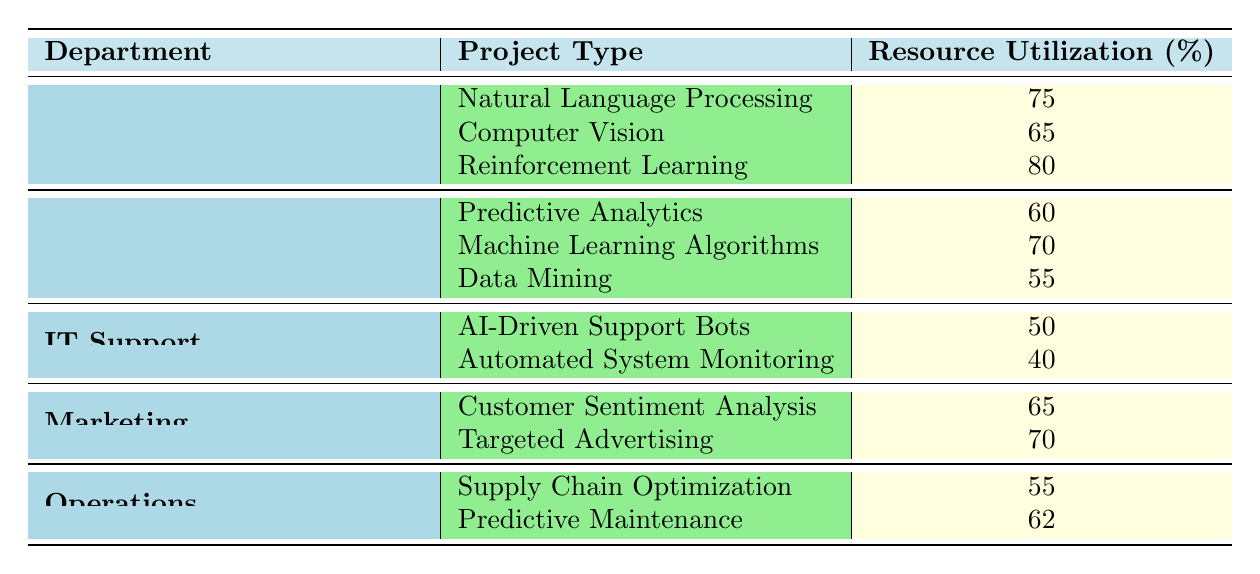What is the resource utilization for Natural Language Processing in the Research and Development department? The table indicates that the resource utilization for Natural Language Processing under the Research and Development department is listed as 75%.
Answer: 75 Which department has the highest resource utilization for its AI project types? By examining the highest individual resource utilization values, Reinforcement Learning in the Research and Development department has the highest value of 80%.
Answer: Research and Development What is the total resource utilization for all AI project types in the Data Science department? The resource utilization values are 60 (Predictive Analytics), 70 (Machine Learning Algorithms), and 55 (Data Mining). Adding these values gives 60 + 70 + 55 = 185.
Answer: 185 Is the resource utilization for AI-Driven Support Bots higher than that of Automated System Monitoring? The resource utilization for AI-Driven Support Bots is 50%, while for Automated System Monitoring it is 40%. Since 50% is greater than 40%, the statement is true.
Answer: Yes What is the average resource utilization across all project types for the Marketing department? The resource utilization values for the Marketing department are 65 (Customer Sentiment Analysis) and 70 (Targeted Advertising). The average is calculated by summing these values (65 + 70 = 135) and dividing by the number of project types (2), resulting in 135 / 2 = 67.5.
Answer: 67.5 Which project type in the Operations department has a resource utilization percentage closest to the value of 60%? In the Operations department, the project types have resource utilizations of 55% (Supply Chain Optimization) and 62% (Predictive Maintenance). The project type Predictive Maintenance (62%) is closer to 60%.
Answer: Predictive Maintenance What is the difference in resource utilization between the highest and lowest project types in the IT Support department? The resource utilization values are 50% (AI-Driven Support Bots) and 40% (Automated System Monitoring). The difference is calculated by subtracting the lower value from the higher value: 50 - 40 = 10%.
Answer: 10 How many departments have a project type with resource utilization above 70%? The Research and Development department has one project type (Reinforcement Learning) at 80%, and the Data Science department does not have any above 70%, whereas the Marketing department has one (Targeted Advertising) at 70%. Therefore, only the Research and Development department meets this criterion.
Answer: One 